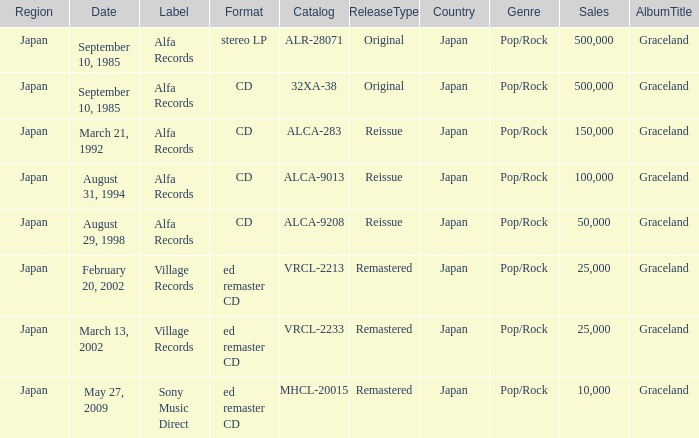Which Catalog was formated as a CD under the label Alfa Records? 32XA-38, ALCA-283, ALCA-9013, ALCA-9208. 